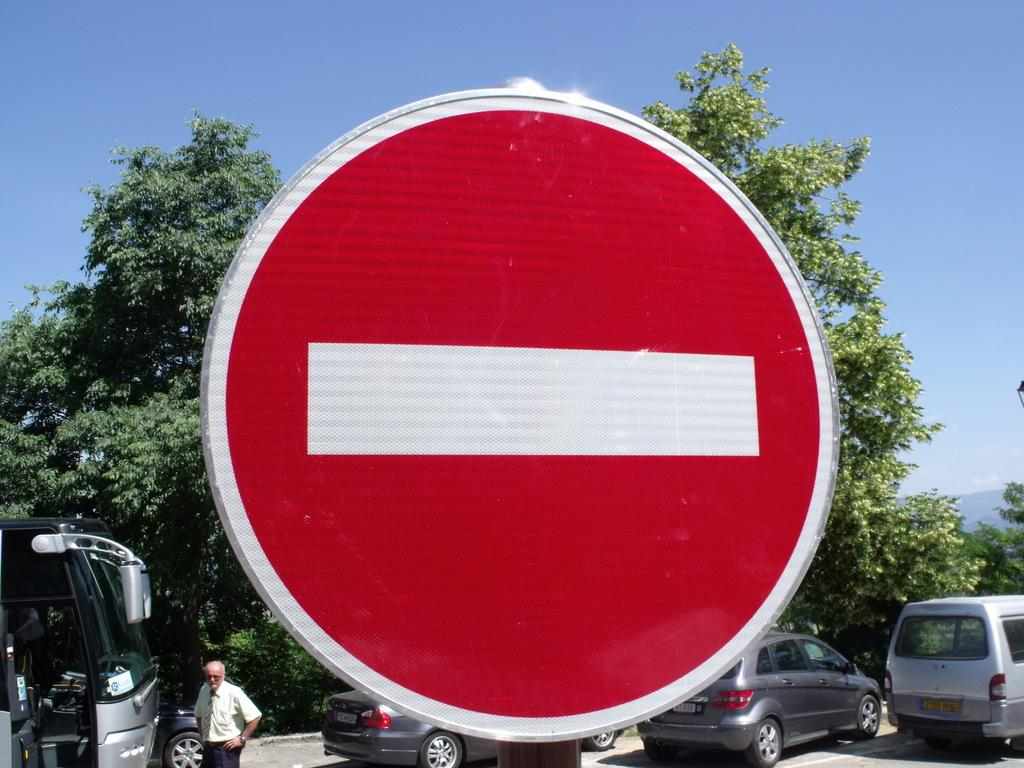What type of sign is visible in the image? There is a danger sign board in the image. What is located behind the sign board? There are vehicles parked behind the sign board. Can you describe the person in the image? A person is standing in the image. What can be seen in the background of the image? There are trees and the sky visible in the background of the image. What type of steam is coming out of the tent in the image? There is no tent or steam present in the image. 